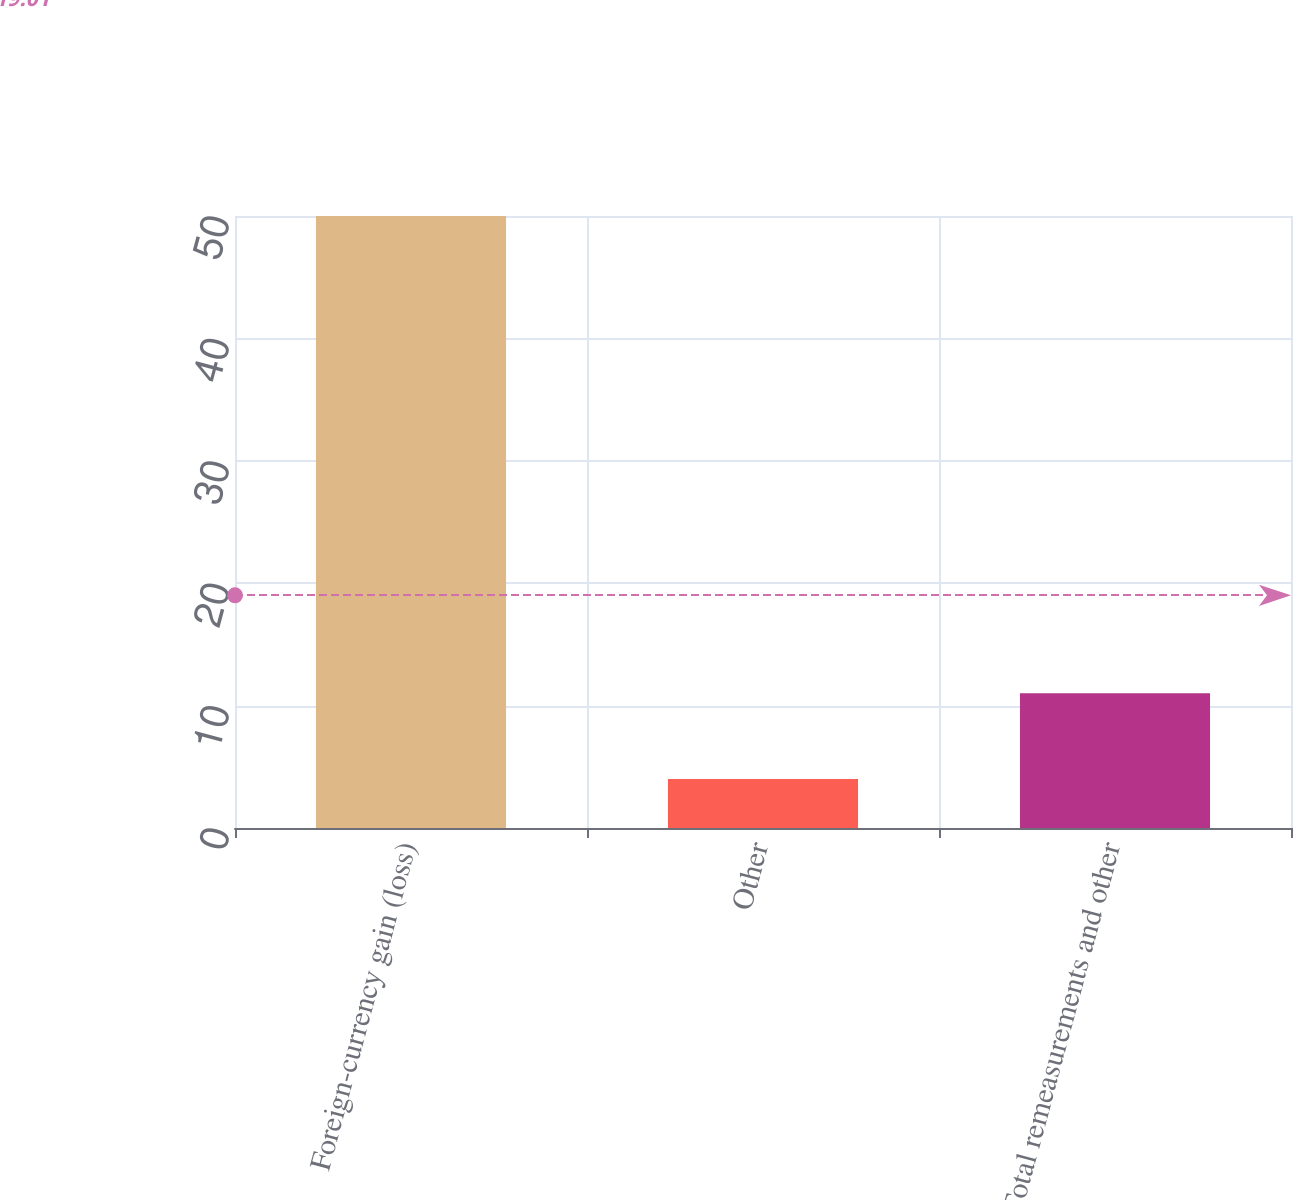<chart> <loc_0><loc_0><loc_500><loc_500><bar_chart><fcel>Foreign-currency gain (loss)<fcel>Other<fcel>Total remeasurements and other<nl><fcel>50<fcel>4<fcel>11<nl></chart> 